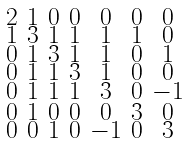<formula> <loc_0><loc_0><loc_500><loc_500>\begin{smallmatrix} 2 & 1 & 0 & 0 & 0 & 0 & 0 \\ 1 & 3 & 1 & 1 & 1 & 1 & 0 \\ 0 & 1 & 3 & 1 & 1 & 0 & 1 \\ 0 & 1 & 1 & 3 & 1 & 0 & 0 \\ 0 & 1 & 1 & 1 & 3 & 0 & - 1 \\ 0 & 1 & 0 & 0 & 0 & 3 & 0 \\ 0 & 0 & 1 & 0 & - 1 & 0 & 3 \end{smallmatrix}</formula> 